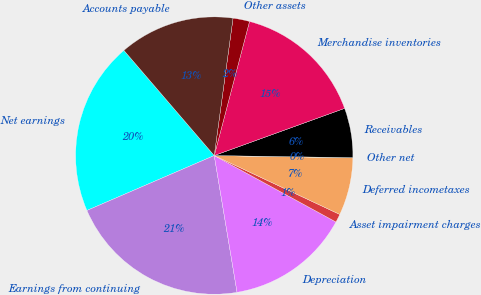Convert chart to OTSL. <chart><loc_0><loc_0><loc_500><loc_500><pie_chart><fcel>Net earnings<fcel>Earnings from continuing<fcel>Depreciation<fcel>Asset impairment charges<fcel>Deferred incometaxes<fcel>Other net<fcel>Receivables<fcel>Merchandise inventories<fcel>Other assets<fcel>Accounts payable<nl><fcel>20.19%<fcel>21.15%<fcel>14.42%<fcel>0.97%<fcel>6.73%<fcel>0.01%<fcel>5.77%<fcel>15.38%<fcel>1.93%<fcel>13.46%<nl></chart> 